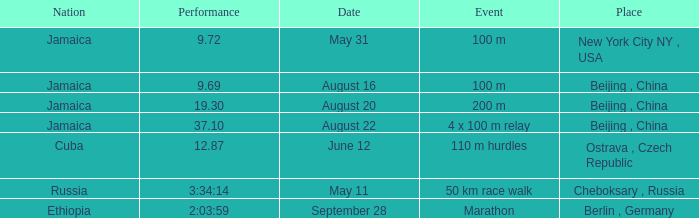What is the Place associated with Cuba? Ostrava , Czech Republic. 